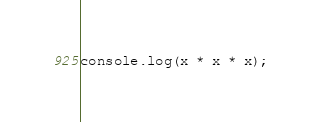Convert code to text. <code><loc_0><loc_0><loc_500><loc_500><_JavaScript_>console.log(x * x * x);</code> 